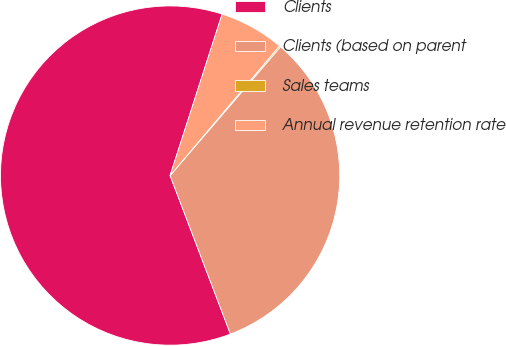Convert chart to OTSL. <chart><loc_0><loc_0><loc_500><loc_500><pie_chart><fcel>Clients<fcel>Clients (based on parent<fcel>Sales teams<fcel>Annual revenue retention rate<nl><fcel>60.76%<fcel>32.93%<fcel>0.13%<fcel>6.19%<nl></chart> 